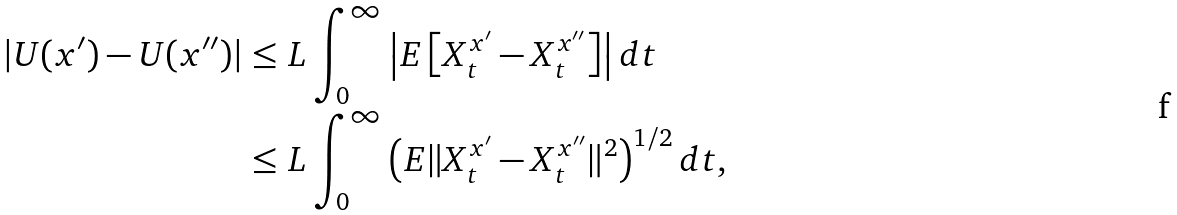<formula> <loc_0><loc_0><loc_500><loc_500>| U ( x ^ { \prime } ) - U ( x ^ { \prime \prime } ) | & \leq L \int _ { 0 } ^ { \infty } \left | E \left [ X ^ { x ^ { \prime } } _ { t } - X ^ { x ^ { \prime \prime } } _ { t } \right ] \right | d t \\ & \leq L \int _ { 0 } ^ { \infty } \left ( E \| X ^ { x ^ { \prime } } _ { t } - X ^ { x ^ { \prime \prime } } _ { t } \| ^ { 2 } \right ) ^ { 1 / 2 } d t ,</formula> 